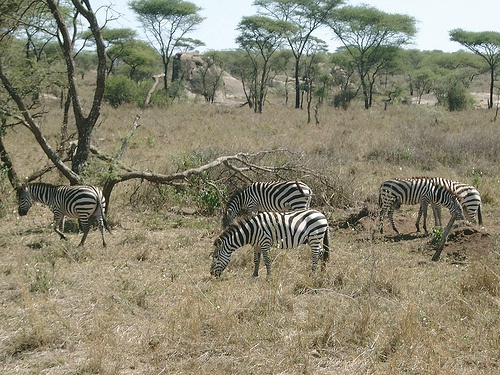Describe the objects in this image and their specific colors. I can see zebra in darkgreen, black, gray, and darkgray tones, zebra in darkgreen, black, gray, and darkgray tones, zebra in darkgreen, black, gray, and darkgray tones, zebra in darkgreen, black, gray, and darkgray tones, and zebra in darkgreen, darkgray, gray, and black tones in this image. 